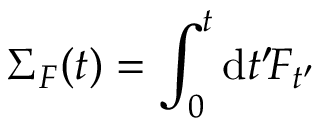Convert formula to latex. <formula><loc_0><loc_0><loc_500><loc_500>\Sigma _ { F } ( t ) = \int _ { 0 } ^ { t } d t ^ { \prime } \, F _ { t ^ { \prime } }</formula> 